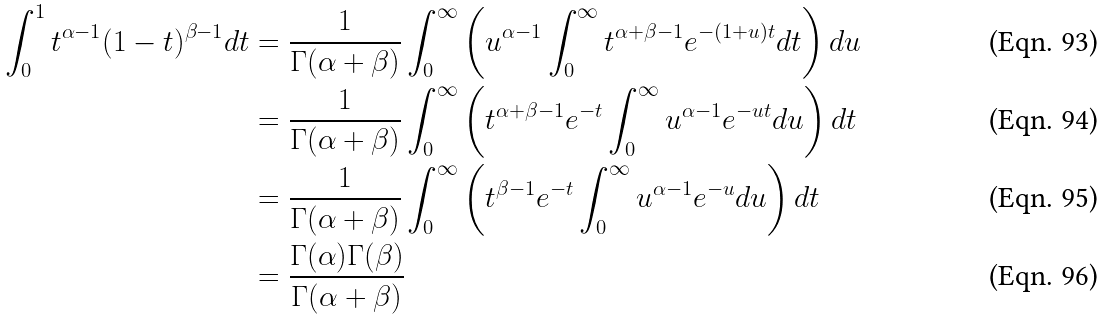<formula> <loc_0><loc_0><loc_500><loc_500>\int _ { 0 } ^ { 1 } t ^ { \alpha - 1 } ( 1 - t ) ^ { \beta - 1 } d t & = \frac { 1 } { \Gamma ( \alpha + \beta ) } \int _ { 0 } ^ { \infty } \left ( u ^ { \alpha - 1 } \int _ { 0 } ^ { \infty } t ^ { \alpha + \beta - 1 } e ^ { - ( 1 + u ) t } d t \right ) d u \\ & = \frac { 1 } { \Gamma ( \alpha + \beta ) } \int _ { 0 } ^ { \infty } \left ( t ^ { \alpha + \beta - 1 } e ^ { - t } \int _ { 0 } ^ { \infty } u ^ { \alpha - 1 } e ^ { - u t } d u \right ) d t \\ & = \frac { 1 } { \Gamma ( \alpha + \beta ) } \int _ { 0 } ^ { \infty } \left ( t ^ { \beta - 1 } e ^ { - t } \int _ { 0 } ^ { \infty } u ^ { \alpha - 1 } e ^ { - u } d u \right ) d t \\ & = \frac { \Gamma ( \alpha ) \Gamma ( \beta ) } { \Gamma ( \alpha + \beta ) }</formula> 